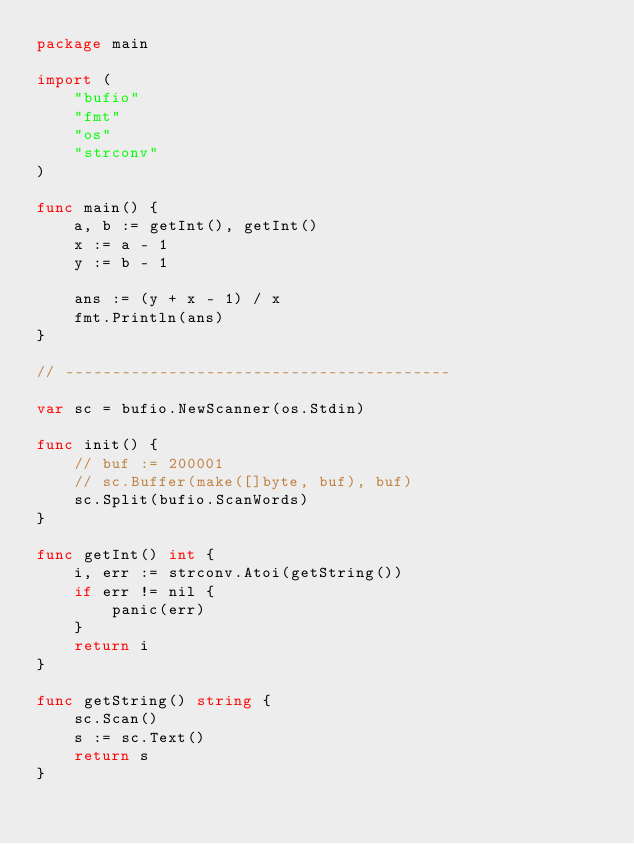Convert code to text. <code><loc_0><loc_0><loc_500><loc_500><_Go_>package main

import (
	"bufio"
	"fmt"
	"os"
	"strconv"
)

func main() {
	a, b := getInt(), getInt()
	x := a - 1
	y := b - 1

	ans := (y + x - 1) / x
	fmt.Println(ans)
}

// -----------------------------------------

var sc = bufio.NewScanner(os.Stdin)

func init() {
	// buf := 200001
	// sc.Buffer(make([]byte, buf), buf)
	sc.Split(bufio.ScanWords)
}

func getInt() int {
	i, err := strconv.Atoi(getString())
	if err != nil {
		panic(err)
	}
	return i
}

func getString() string {
	sc.Scan()
	s := sc.Text()
	return s
}
</code> 